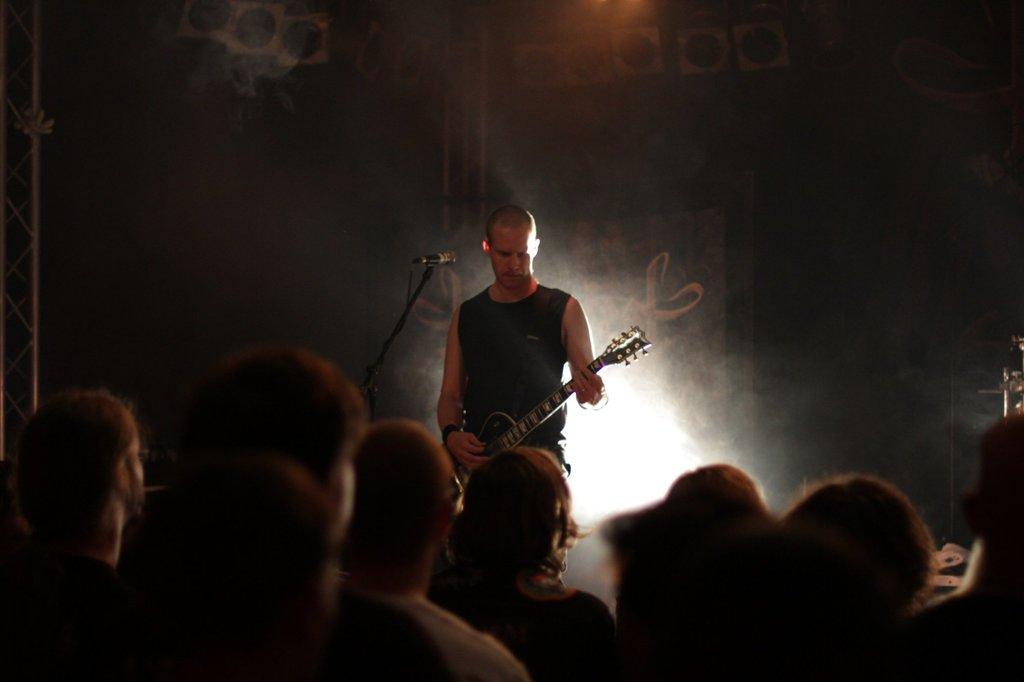What is the man in the image holding? The man is holding a guitar. What is the man doing with the guitar? The man is playing the guitar. Where is the man positioned in relation to the microphone? The man is in front of a microphone. What is the role of the group of people in the background? The group of people are acting as an audience. What can be seen in the background besides the audience? There are hoardings visible in the background, and there are lights present near the hoardings. What type of blade is the tiger using to cut the square in the image? There is no tiger or square present in the image, and therefore no such activity can be observed. 